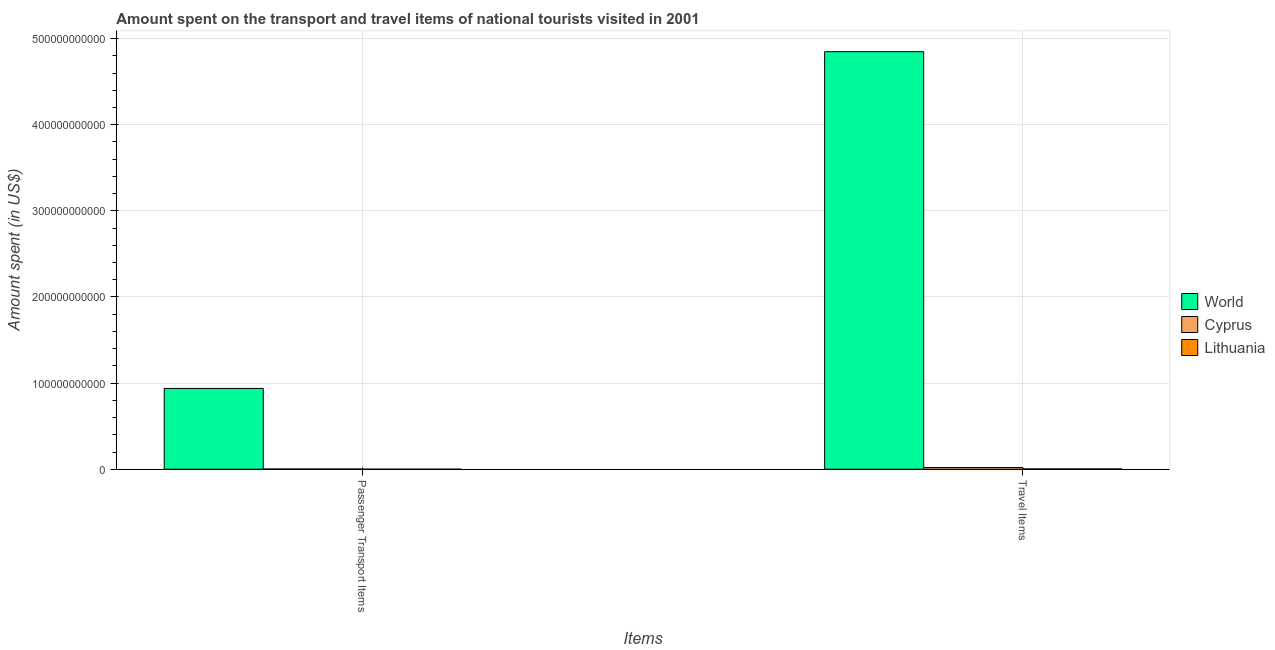How many different coloured bars are there?
Provide a succinct answer. 3. How many groups of bars are there?
Offer a very short reply. 2. Are the number of bars per tick equal to the number of legend labels?
Provide a succinct answer. Yes. How many bars are there on the 2nd tick from the left?
Keep it short and to the point. 3. What is the label of the 1st group of bars from the left?
Provide a succinct answer. Passenger Transport Items. What is the amount spent on passenger transport items in Cyprus?
Offer a terse response. 2.10e+08. Across all countries, what is the maximum amount spent on passenger transport items?
Provide a short and direct response. 9.38e+1. Across all countries, what is the minimum amount spent in travel items?
Offer a very short reply. 3.83e+08. In which country was the amount spent on passenger transport items maximum?
Offer a very short reply. World. In which country was the amount spent in travel items minimum?
Offer a terse response. Lithuania. What is the total amount spent in travel items in the graph?
Your answer should be compact. 4.87e+11. What is the difference between the amount spent on passenger transport items in Lithuania and that in Cyprus?
Your answer should be very brief. -1.68e+08. What is the difference between the amount spent on passenger transport items in Cyprus and the amount spent in travel items in Lithuania?
Your answer should be very brief. -1.73e+08. What is the average amount spent in travel items per country?
Your response must be concise. 1.62e+11. What is the difference between the amount spent on passenger transport items and amount spent in travel items in World?
Keep it short and to the point. -3.91e+11. What is the ratio of the amount spent in travel items in Lithuania to that in World?
Your answer should be very brief. 0. In how many countries, is the amount spent on passenger transport items greater than the average amount spent on passenger transport items taken over all countries?
Make the answer very short. 1. What does the 3rd bar from the left in Passenger Transport Items represents?
Your answer should be compact. Lithuania. Are all the bars in the graph horizontal?
Your answer should be very brief. No. What is the difference between two consecutive major ticks on the Y-axis?
Provide a short and direct response. 1.00e+11. Does the graph contain any zero values?
Ensure brevity in your answer.  No. Does the graph contain grids?
Offer a terse response. Yes. How many legend labels are there?
Make the answer very short. 3. What is the title of the graph?
Ensure brevity in your answer.  Amount spent on the transport and travel items of national tourists visited in 2001. What is the label or title of the X-axis?
Provide a short and direct response. Items. What is the label or title of the Y-axis?
Keep it short and to the point. Amount spent (in US$). What is the Amount spent (in US$) of World in Passenger Transport Items?
Your response must be concise. 9.38e+1. What is the Amount spent (in US$) in Cyprus in Passenger Transport Items?
Provide a short and direct response. 2.10e+08. What is the Amount spent (in US$) in Lithuania in Passenger Transport Items?
Your answer should be very brief. 4.20e+07. What is the Amount spent (in US$) in World in Travel Items?
Ensure brevity in your answer.  4.85e+11. What is the Amount spent (in US$) of Cyprus in Travel Items?
Give a very brief answer. 1.99e+09. What is the Amount spent (in US$) in Lithuania in Travel Items?
Give a very brief answer. 3.83e+08. Across all Items, what is the maximum Amount spent (in US$) in World?
Offer a very short reply. 4.85e+11. Across all Items, what is the maximum Amount spent (in US$) in Cyprus?
Ensure brevity in your answer.  1.99e+09. Across all Items, what is the maximum Amount spent (in US$) in Lithuania?
Offer a terse response. 3.83e+08. Across all Items, what is the minimum Amount spent (in US$) in World?
Offer a very short reply. 9.38e+1. Across all Items, what is the minimum Amount spent (in US$) of Cyprus?
Give a very brief answer. 2.10e+08. Across all Items, what is the minimum Amount spent (in US$) in Lithuania?
Provide a succinct answer. 4.20e+07. What is the total Amount spent (in US$) in World in the graph?
Keep it short and to the point. 5.79e+11. What is the total Amount spent (in US$) of Cyprus in the graph?
Make the answer very short. 2.20e+09. What is the total Amount spent (in US$) of Lithuania in the graph?
Your answer should be very brief. 4.25e+08. What is the difference between the Amount spent (in US$) in World in Passenger Transport Items and that in Travel Items?
Provide a short and direct response. -3.91e+11. What is the difference between the Amount spent (in US$) of Cyprus in Passenger Transport Items and that in Travel Items?
Your answer should be very brief. -1.78e+09. What is the difference between the Amount spent (in US$) in Lithuania in Passenger Transport Items and that in Travel Items?
Make the answer very short. -3.41e+08. What is the difference between the Amount spent (in US$) of World in Passenger Transport Items and the Amount spent (in US$) of Cyprus in Travel Items?
Offer a very short reply. 9.18e+1. What is the difference between the Amount spent (in US$) of World in Passenger Transport Items and the Amount spent (in US$) of Lithuania in Travel Items?
Give a very brief answer. 9.34e+1. What is the difference between the Amount spent (in US$) of Cyprus in Passenger Transport Items and the Amount spent (in US$) of Lithuania in Travel Items?
Your response must be concise. -1.73e+08. What is the average Amount spent (in US$) of World per Items?
Offer a very short reply. 2.89e+11. What is the average Amount spent (in US$) of Cyprus per Items?
Ensure brevity in your answer.  1.10e+09. What is the average Amount spent (in US$) of Lithuania per Items?
Offer a terse response. 2.12e+08. What is the difference between the Amount spent (in US$) of World and Amount spent (in US$) of Cyprus in Passenger Transport Items?
Give a very brief answer. 9.36e+1. What is the difference between the Amount spent (in US$) of World and Amount spent (in US$) of Lithuania in Passenger Transport Items?
Provide a succinct answer. 9.38e+1. What is the difference between the Amount spent (in US$) in Cyprus and Amount spent (in US$) in Lithuania in Passenger Transport Items?
Provide a succinct answer. 1.68e+08. What is the difference between the Amount spent (in US$) in World and Amount spent (in US$) in Cyprus in Travel Items?
Ensure brevity in your answer.  4.83e+11. What is the difference between the Amount spent (in US$) of World and Amount spent (in US$) of Lithuania in Travel Items?
Ensure brevity in your answer.  4.84e+11. What is the difference between the Amount spent (in US$) of Cyprus and Amount spent (in US$) of Lithuania in Travel Items?
Your answer should be very brief. 1.61e+09. What is the ratio of the Amount spent (in US$) in World in Passenger Transport Items to that in Travel Items?
Offer a terse response. 0.19. What is the ratio of the Amount spent (in US$) of Cyprus in Passenger Transport Items to that in Travel Items?
Your answer should be very brief. 0.11. What is the ratio of the Amount spent (in US$) of Lithuania in Passenger Transport Items to that in Travel Items?
Offer a terse response. 0.11. What is the difference between the highest and the second highest Amount spent (in US$) in World?
Keep it short and to the point. 3.91e+11. What is the difference between the highest and the second highest Amount spent (in US$) in Cyprus?
Your answer should be very brief. 1.78e+09. What is the difference between the highest and the second highest Amount spent (in US$) of Lithuania?
Offer a very short reply. 3.41e+08. What is the difference between the highest and the lowest Amount spent (in US$) in World?
Give a very brief answer. 3.91e+11. What is the difference between the highest and the lowest Amount spent (in US$) of Cyprus?
Your response must be concise. 1.78e+09. What is the difference between the highest and the lowest Amount spent (in US$) of Lithuania?
Provide a short and direct response. 3.41e+08. 